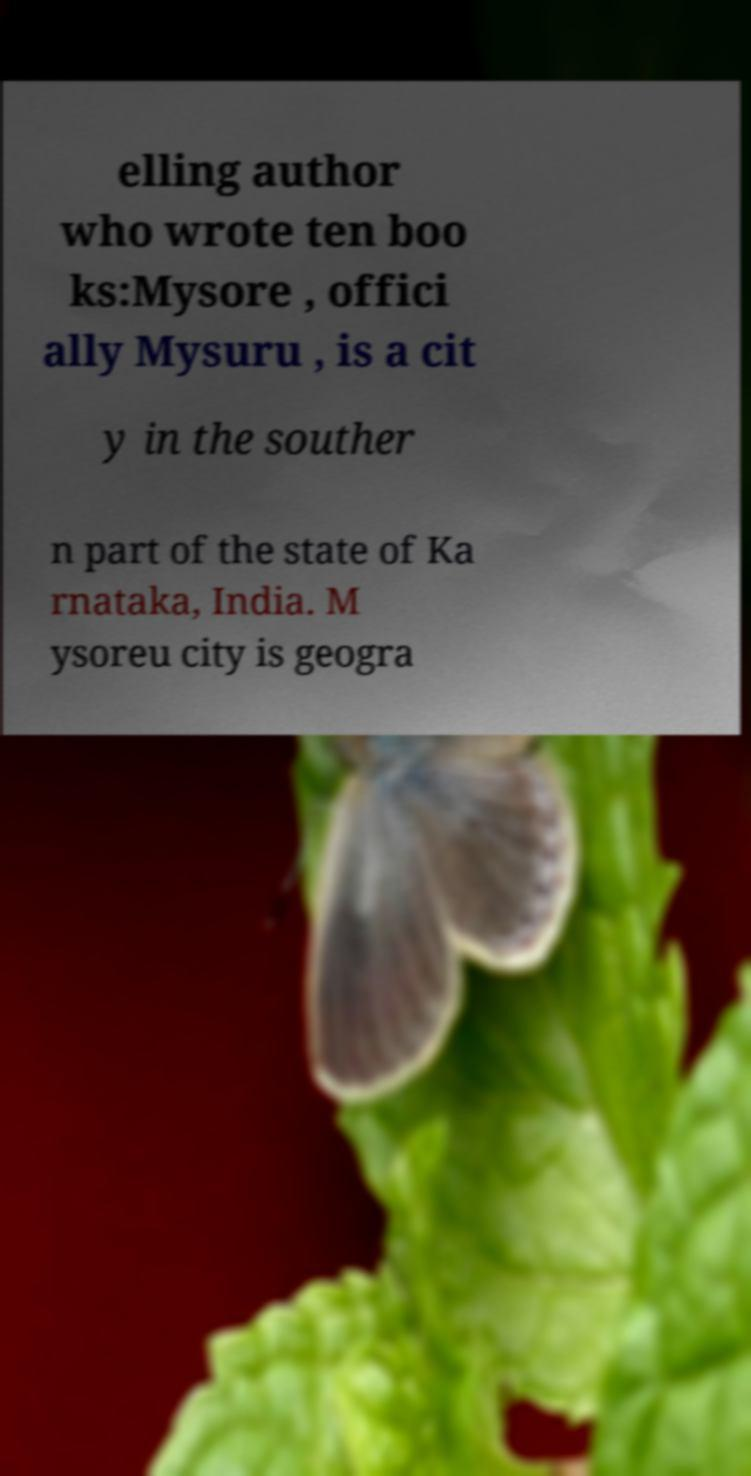I need the written content from this picture converted into text. Can you do that? elling author who wrote ten boo ks:Mysore , offici ally Mysuru , is a cit y in the souther n part of the state of Ka rnataka, India. M ysoreu city is geogra 